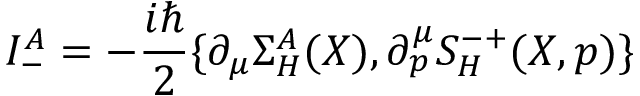<formula> <loc_0><loc_0><loc_500><loc_500>I _ { - } ^ { A } = - \frac { i } 2 \{ \partial _ { \mu } \Sigma _ { H } ^ { A } ( X ) , \partial _ { p } ^ { \mu } S _ { H } ^ { - + } ( X , p ) \}</formula> 